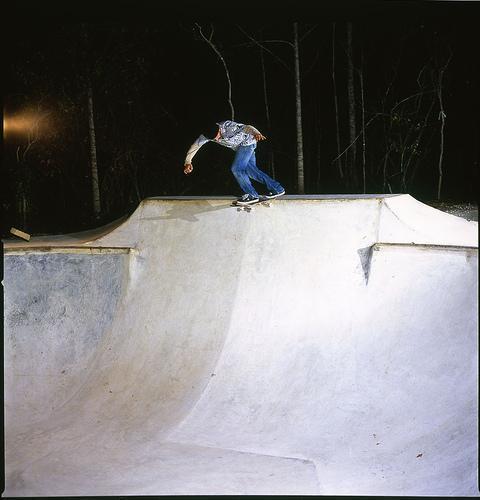How many skateboards are there?
Give a very brief answer. 1. 